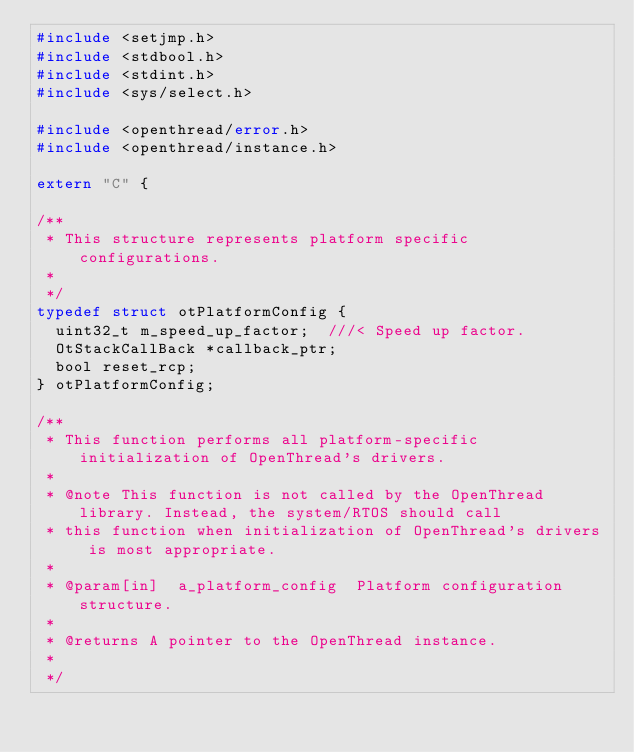Convert code to text. <code><loc_0><loc_0><loc_500><loc_500><_C_>#include <setjmp.h>
#include <stdbool.h>
#include <stdint.h>
#include <sys/select.h>

#include <openthread/error.h>
#include <openthread/instance.h>

extern "C" {

/**
 * This structure represents platform specific configurations.
 *
 */
typedef struct otPlatformConfig {
  uint32_t m_speed_up_factor;  ///< Speed up factor.
  OtStackCallBack *callback_ptr;
  bool reset_rcp;
} otPlatformConfig;

/**
 * This function performs all platform-specific initialization of OpenThread's drivers.
 *
 * @note This function is not called by the OpenThread library. Instead, the system/RTOS should call
 * this function when initialization of OpenThread's drivers is most appropriate.
 *
 * @param[in]  a_platform_config  Platform configuration structure.
 *
 * @returns A pointer to the OpenThread instance.
 *
 */</code> 